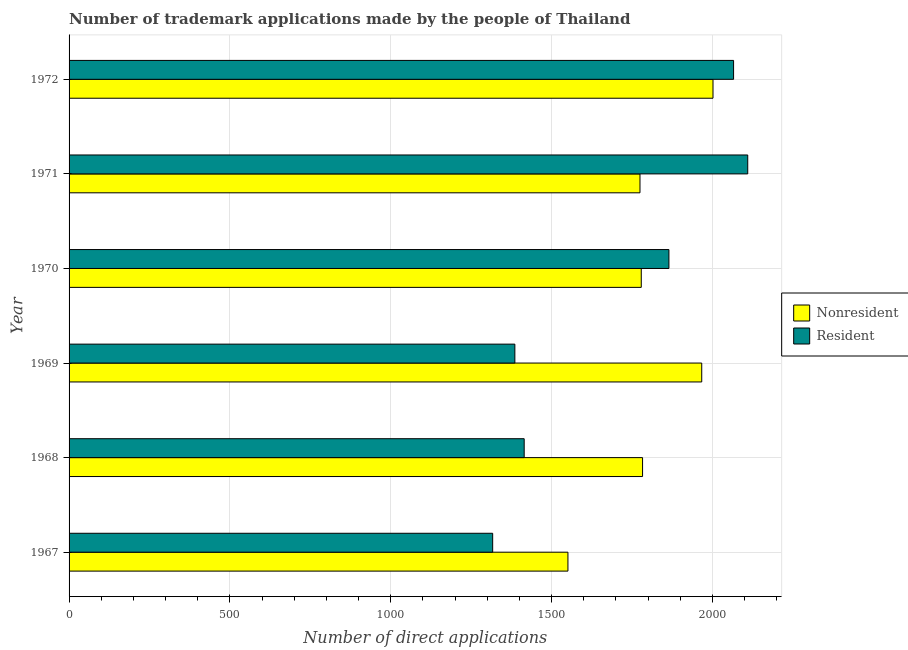How many bars are there on the 1st tick from the top?
Keep it short and to the point. 2. In how many cases, is the number of bars for a given year not equal to the number of legend labels?
Keep it short and to the point. 0. What is the number of trademark applications made by residents in 1970?
Ensure brevity in your answer.  1865. Across all years, what is the minimum number of trademark applications made by residents?
Offer a terse response. 1317. In which year was the number of trademark applications made by non residents maximum?
Keep it short and to the point. 1972. In which year was the number of trademark applications made by residents minimum?
Provide a succinct answer. 1967. What is the total number of trademark applications made by non residents in the graph?
Offer a terse response. 1.09e+04. What is the difference between the number of trademark applications made by non residents in 1969 and that in 1972?
Provide a succinct answer. -35. What is the difference between the number of trademark applications made by non residents in 1971 and the number of trademark applications made by residents in 1970?
Keep it short and to the point. -90. What is the average number of trademark applications made by non residents per year?
Make the answer very short. 1809.5. In the year 1970, what is the difference between the number of trademark applications made by residents and number of trademark applications made by non residents?
Give a very brief answer. 86. What is the ratio of the number of trademark applications made by residents in 1970 to that in 1972?
Offer a terse response. 0.9. Is the number of trademark applications made by non residents in 1967 less than that in 1971?
Provide a short and direct response. Yes. Is the difference between the number of trademark applications made by residents in 1967 and 1968 greater than the difference between the number of trademark applications made by non residents in 1967 and 1968?
Provide a succinct answer. Yes. What is the difference between the highest and the second highest number of trademark applications made by non residents?
Offer a terse response. 35. What is the difference between the highest and the lowest number of trademark applications made by non residents?
Offer a terse response. 451. Is the sum of the number of trademark applications made by non residents in 1969 and 1971 greater than the maximum number of trademark applications made by residents across all years?
Your answer should be very brief. Yes. What does the 2nd bar from the top in 1967 represents?
Offer a terse response. Nonresident. What does the 2nd bar from the bottom in 1969 represents?
Offer a very short reply. Resident. Are all the bars in the graph horizontal?
Provide a short and direct response. Yes. How many years are there in the graph?
Ensure brevity in your answer.  6. Does the graph contain any zero values?
Keep it short and to the point. No. Does the graph contain grids?
Make the answer very short. Yes. How many legend labels are there?
Provide a short and direct response. 2. How are the legend labels stacked?
Offer a terse response. Vertical. What is the title of the graph?
Ensure brevity in your answer.  Number of trademark applications made by the people of Thailand. What is the label or title of the X-axis?
Your answer should be very brief. Number of direct applications. What is the label or title of the Y-axis?
Offer a very short reply. Year. What is the Number of direct applications of Nonresident in 1967?
Your response must be concise. 1551. What is the Number of direct applications in Resident in 1967?
Ensure brevity in your answer.  1317. What is the Number of direct applications in Nonresident in 1968?
Provide a short and direct response. 1783. What is the Number of direct applications of Resident in 1968?
Make the answer very short. 1415. What is the Number of direct applications in Nonresident in 1969?
Keep it short and to the point. 1967. What is the Number of direct applications in Resident in 1969?
Offer a very short reply. 1386. What is the Number of direct applications in Nonresident in 1970?
Give a very brief answer. 1779. What is the Number of direct applications in Resident in 1970?
Your answer should be very brief. 1865. What is the Number of direct applications in Nonresident in 1971?
Offer a terse response. 1775. What is the Number of direct applications in Resident in 1971?
Make the answer very short. 2110. What is the Number of direct applications in Nonresident in 1972?
Offer a very short reply. 2002. What is the Number of direct applications of Resident in 1972?
Offer a terse response. 2066. Across all years, what is the maximum Number of direct applications of Nonresident?
Your answer should be compact. 2002. Across all years, what is the maximum Number of direct applications in Resident?
Your answer should be very brief. 2110. Across all years, what is the minimum Number of direct applications in Nonresident?
Provide a succinct answer. 1551. Across all years, what is the minimum Number of direct applications of Resident?
Provide a succinct answer. 1317. What is the total Number of direct applications in Nonresident in the graph?
Offer a very short reply. 1.09e+04. What is the total Number of direct applications in Resident in the graph?
Your answer should be very brief. 1.02e+04. What is the difference between the Number of direct applications of Nonresident in 1967 and that in 1968?
Offer a very short reply. -232. What is the difference between the Number of direct applications in Resident in 1967 and that in 1968?
Your answer should be very brief. -98. What is the difference between the Number of direct applications of Nonresident in 1967 and that in 1969?
Make the answer very short. -416. What is the difference between the Number of direct applications in Resident in 1967 and that in 1969?
Offer a terse response. -69. What is the difference between the Number of direct applications of Nonresident in 1967 and that in 1970?
Provide a succinct answer. -228. What is the difference between the Number of direct applications of Resident in 1967 and that in 1970?
Ensure brevity in your answer.  -548. What is the difference between the Number of direct applications of Nonresident in 1967 and that in 1971?
Give a very brief answer. -224. What is the difference between the Number of direct applications of Resident in 1967 and that in 1971?
Provide a succinct answer. -793. What is the difference between the Number of direct applications of Nonresident in 1967 and that in 1972?
Make the answer very short. -451. What is the difference between the Number of direct applications in Resident in 1967 and that in 1972?
Provide a succinct answer. -749. What is the difference between the Number of direct applications in Nonresident in 1968 and that in 1969?
Ensure brevity in your answer.  -184. What is the difference between the Number of direct applications of Resident in 1968 and that in 1969?
Provide a succinct answer. 29. What is the difference between the Number of direct applications in Resident in 1968 and that in 1970?
Provide a short and direct response. -450. What is the difference between the Number of direct applications in Resident in 1968 and that in 1971?
Give a very brief answer. -695. What is the difference between the Number of direct applications in Nonresident in 1968 and that in 1972?
Provide a succinct answer. -219. What is the difference between the Number of direct applications of Resident in 1968 and that in 1972?
Your answer should be very brief. -651. What is the difference between the Number of direct applications of Nonresident in 1969 and that in 1970?
Your response must be concise. 188. What is the difference between the Number of direct applications of Resident in 1969 and that in 1970?
Your answer should be compact. -479. What is the difference between the Number of direct applications in Nonresident in 1969 and that in 1971?
Your answer should be compact. 192. What is the difference between the Number of direct applications of Resident in 1969 and that in 1971?
Make the answer very short. -724. What is the difference between the Number of direct applications in Nonresident in 1969 and that in 1972?
Your response must be concise. -35. What is the difference between the Number of direct applications of Resident in 1969 and that in 1972?
Your answer should be compact. -680. What is the difference between the Number of direct applications in Nonresident in 1970 and that in 1971?
Provide a short and direct response. 4. What is the difference between the Number of direct applications of Resident in 1970 and that in 1971?
Offer a terse response. -245. What is the difference between the Number of direct applications of Nonresident in 1970 and that in 1972?
Offer a very short reply. -223. What is the difference between the Number of direct applications in Resident in 1970 and that in 1972?
Give a very brief answer. -201. What is the difference between the Number of direct applications of Nonresident in 1971 and that in 1972?
Your answer should be compact. -227. What is the difference between the Number of direct applications in Resident in 1971 and that in 1972?
Offer a very short reply. 44. What is the difference between the Number of direct applications of Nonresident in 1967 and the Number of direct applications of Resident in 1968?
Provide a succinct answer. 136. What is the difference between the Number of direct applications of Nonresident in 1967 and the Number of direct applications of Resident in 1969?
Offer a terse response. 165. What is the difference between the Number of direct applications in Nonresident in 1967 and the Number of direct applications in Resident in 1970?
Ensure brevity in your answer.  -314. What is the difference between the Number of direct applications of Nonresident in 1967 and the Number of direct applications of Resident in 1971?
Make the answer very short. -559. What is the difference between the Number of direct applications in Nonresident in 1967 and the Number of direct applications in Resident in 1972?
Your answer should be very brief. -515. What is the difference between the Number of direct applications of Nonresident in 1968 and the Number of direct applications of Resident in 1969?
Provide a short and direct response. 397. What is the difference between the Number of direct applications of Nonresident in 1968 and the Number of direct applications of Resident in 1970?
Offer a very short reply. -82. What is the difference between the Number of direct applications of Nonresident in 1968 and the Number of direct applications of Resident in 1971?
Give a very brief answer. -327. What is the difference between the Number of direct applications of Nonresident in 1968 and the Number of direct applications of Resident in 1972?
Your answer should be compact. -283. What is the difference between the Number of direct applications in Nonresident in 1969 and the Number of direct applications in Resident in 1970?
Make the answer very short. 102. What is the difference between the Number of direct applications of Nonresident in 1969 and the Number of direct applications of Resident in 1971?
Give a very brief answer. -143. What is the difference between the Number of direct applications of Nonresident in 1969 and the Number of direct applications of Resident in 1972?
Provide a succinct answer. -99. What is the difference between the Number of direct applications of Nonresident in 1970 and the Number of direct applications of Resident in 1971?
Offer a very short reply. -331. What is the difference between the Number of direct applications in Nonresident in 1970 and the Number of direct applications in Resident in 1972?
Make the answer very short. -287. What is the difference between the Number of direct applications of Nonresident in 1971 and the Number of direct applications of Resident in 1972?
Offer a very short reply. -291. What is the average Number of direct applications of Nonresident per year?
Your response must be concise. 1809.5. What is the average Number of direct applications of Resident per year?
Offer a terse response. 1693.17. In the year 1967, what is the difference between the Number of direct applications of Nonresident and Number of direct applications of Resident?
Ensure brevity in your answer.  234. In the year 1968, what is the difference between the Number of direct applications in Nonresident and Number of direct applications in Resident?
Keep it short and to the point. 368. In the year 1969, what is the difference between the Number of direct applications in Nonresident and Number of direct applications in Resident?
Your answer should be very brief. 581. In the year 1970, what is the difference between the Number of direct applications in Nonresident and Number of direct applications in Resident?
Make the answer very short. -86. In the year 1971, what is the difference between the Number of direct applications of Nonresident and Number of direct applications of Resident?
Keep it short and to the point. -335. In the year 1972, what is the difference between the Number of direct applications in Nonresident and Number of direct applications in Resident?
Keep it short and to the point. -64. What is the ratio of the Number of direct applications in Nonresident in 1967 to that in 1968?
Ensure brevity in your answer.  0.87. What is the ratio of the Number of direct applications in Resident in 1967 to that in 1968?
Offer a very short reply. 0.93. What is the ratio of the Number of direct applications in Nonresident in 1967 to that in 1969?
Make the answer very short. 0.79. What is the ratio of the Number of direct applications of Resident in 1967 to that in 1969?
Make the answer very short. 0.95. What is the ratio of the Number of direct applications in Nonresident in 1967 to that in 1970?
Your response must be concise. 0.87. What is the ratio of the Number of direct applications in Resident in 1967 to that in 1970?
Offer a very short reply. 0.71. What is the ratio of the Number of direct applications in Nonresident in 1967 to that in 1971?
Your answer should be very brief. 0.87. What is the ratio of the Number of direct applications in Resident in 1967 to that in 1971?
Give a very brief answer. 0.62. What is the ratio of the Number of direct applications in Nonresident in 1967 to that in 1972?
Provide a short and direct response. 0.77. What is the ratio of the Number of direct applications in Resident in 1967 to that in 1972?
Offer a terse response. 0.64. What is the ratio of the Number of direct applications of Nonresident in 1968 to that in 1969?
Make the answer very short. 0.91. What is the ratio of the Number of direct applications in Resident in 1968 to that in 1969?
Your answer should be very brief. 1.02. What is the ratio of the Number of direct applications of Resident in 1968 to that in 1970?
Your answer should be very brief. 0.76. What is the ratio of the Number of direct applications of Nonresident in 1968 to that in 1971?
Make the answer very short. 1. What is the ratio of the Number of direct applications of Resident in 1968 to that in 1971?
Provide a short and direct response. 0.67. What is the ratio of the Number of direct applications in Nonresident in 1968 to that in 1972?
Ensure brevity in your answer.  0.89. What is the ratio of the Number of direct applications in Resident in 1968 to that in 1972?
Provide a succinct answer. 0.68. What is the ratio of the Number of direct applications in Nonresident in 1969 to that in 1970?
Make the answer very short. 1.11. What is the ratio of the Number of direct applications of Resident in 1969 to that in 1970?
Give a very brief answer. 0.74. What is the ratio of the Number of direct applications in Nonresident in 1969 to that in 1971?
Make the answer very short. 1.11. What is the ratio of the Number of direct applications in Resident in 1969 to that in 1971?
Offer a very short reply. 0.66. What is the ratio of the Number of direct applications in Nonresident in 1969 to that in 1972?
Provide a succinct answer. 0.98. What is the ratio of the Number of direct applications of Resident in 1969 to that in 1972?
Ensure brevity in your answer.  0.67. What is the ratio of the Number of direct applications in Nonresident in 1970 to that in 1971?
Make the answer very short. 1. What is the ratio of the Number of direct applications in Resident in 1970 to that in 1971?
Provide a succinct answer. 0.88. What is the ratio of the Number of direct applications of Nonresident in 1970 to that in 1972?
Your answer should be very brief. 0.89. What is the ratio of the Number of direct applications in Resident in 1970 to that in 1972?
Make the answer very short. 0.9. What is the ratio of the Number of direct applications in Nonresident in 1971 to that in 1972?
Your answer should be compact. 0.89. What is the ratio of the Number of direct applications in Resident in 1971 to that in 1972?
Provide a succinct answer. 1.02. What is the difference between the highest and the second highest Number of direct applications in Nonresident?
Give a very brief answer. 35. What is the difference between the highest and the lowest Number of direct applications of Nonresident?
Offer a very short reply. 451. What is the difference between the highest and the lowest Number of direct applications of Resident?
Provide a short and direct response. 793. 